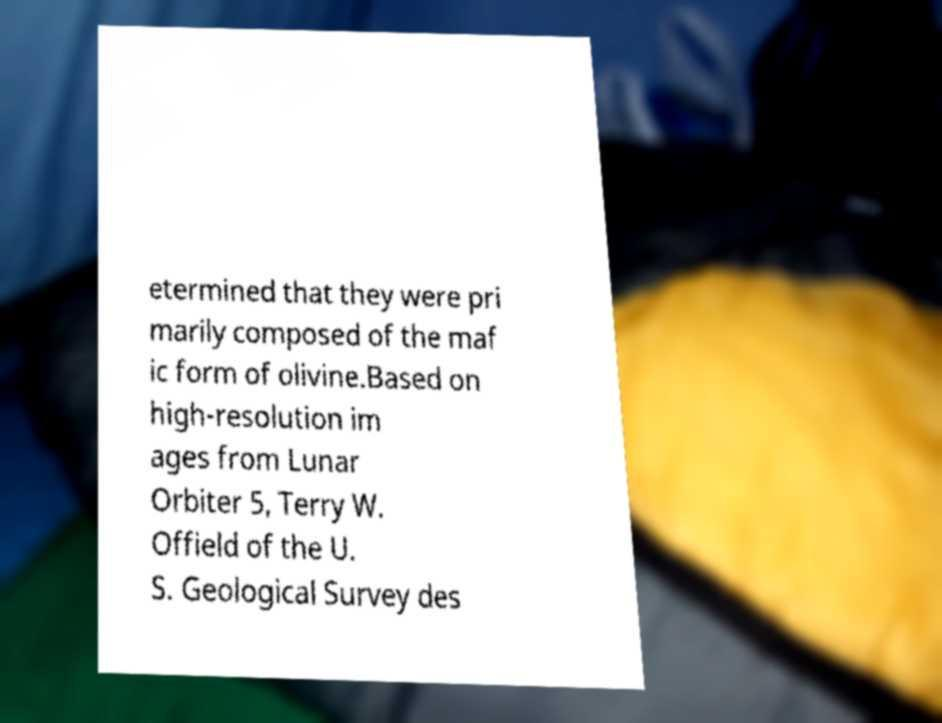For documentation purposes, I need the text within this image transcribed. Could you provide that? etermined that they were pri marily composed of the maf ic form of olivine.Based on high-resolution im ages from Lunar Orbiter 5, Terry W. Offield of the U. S. Geological Survey des 